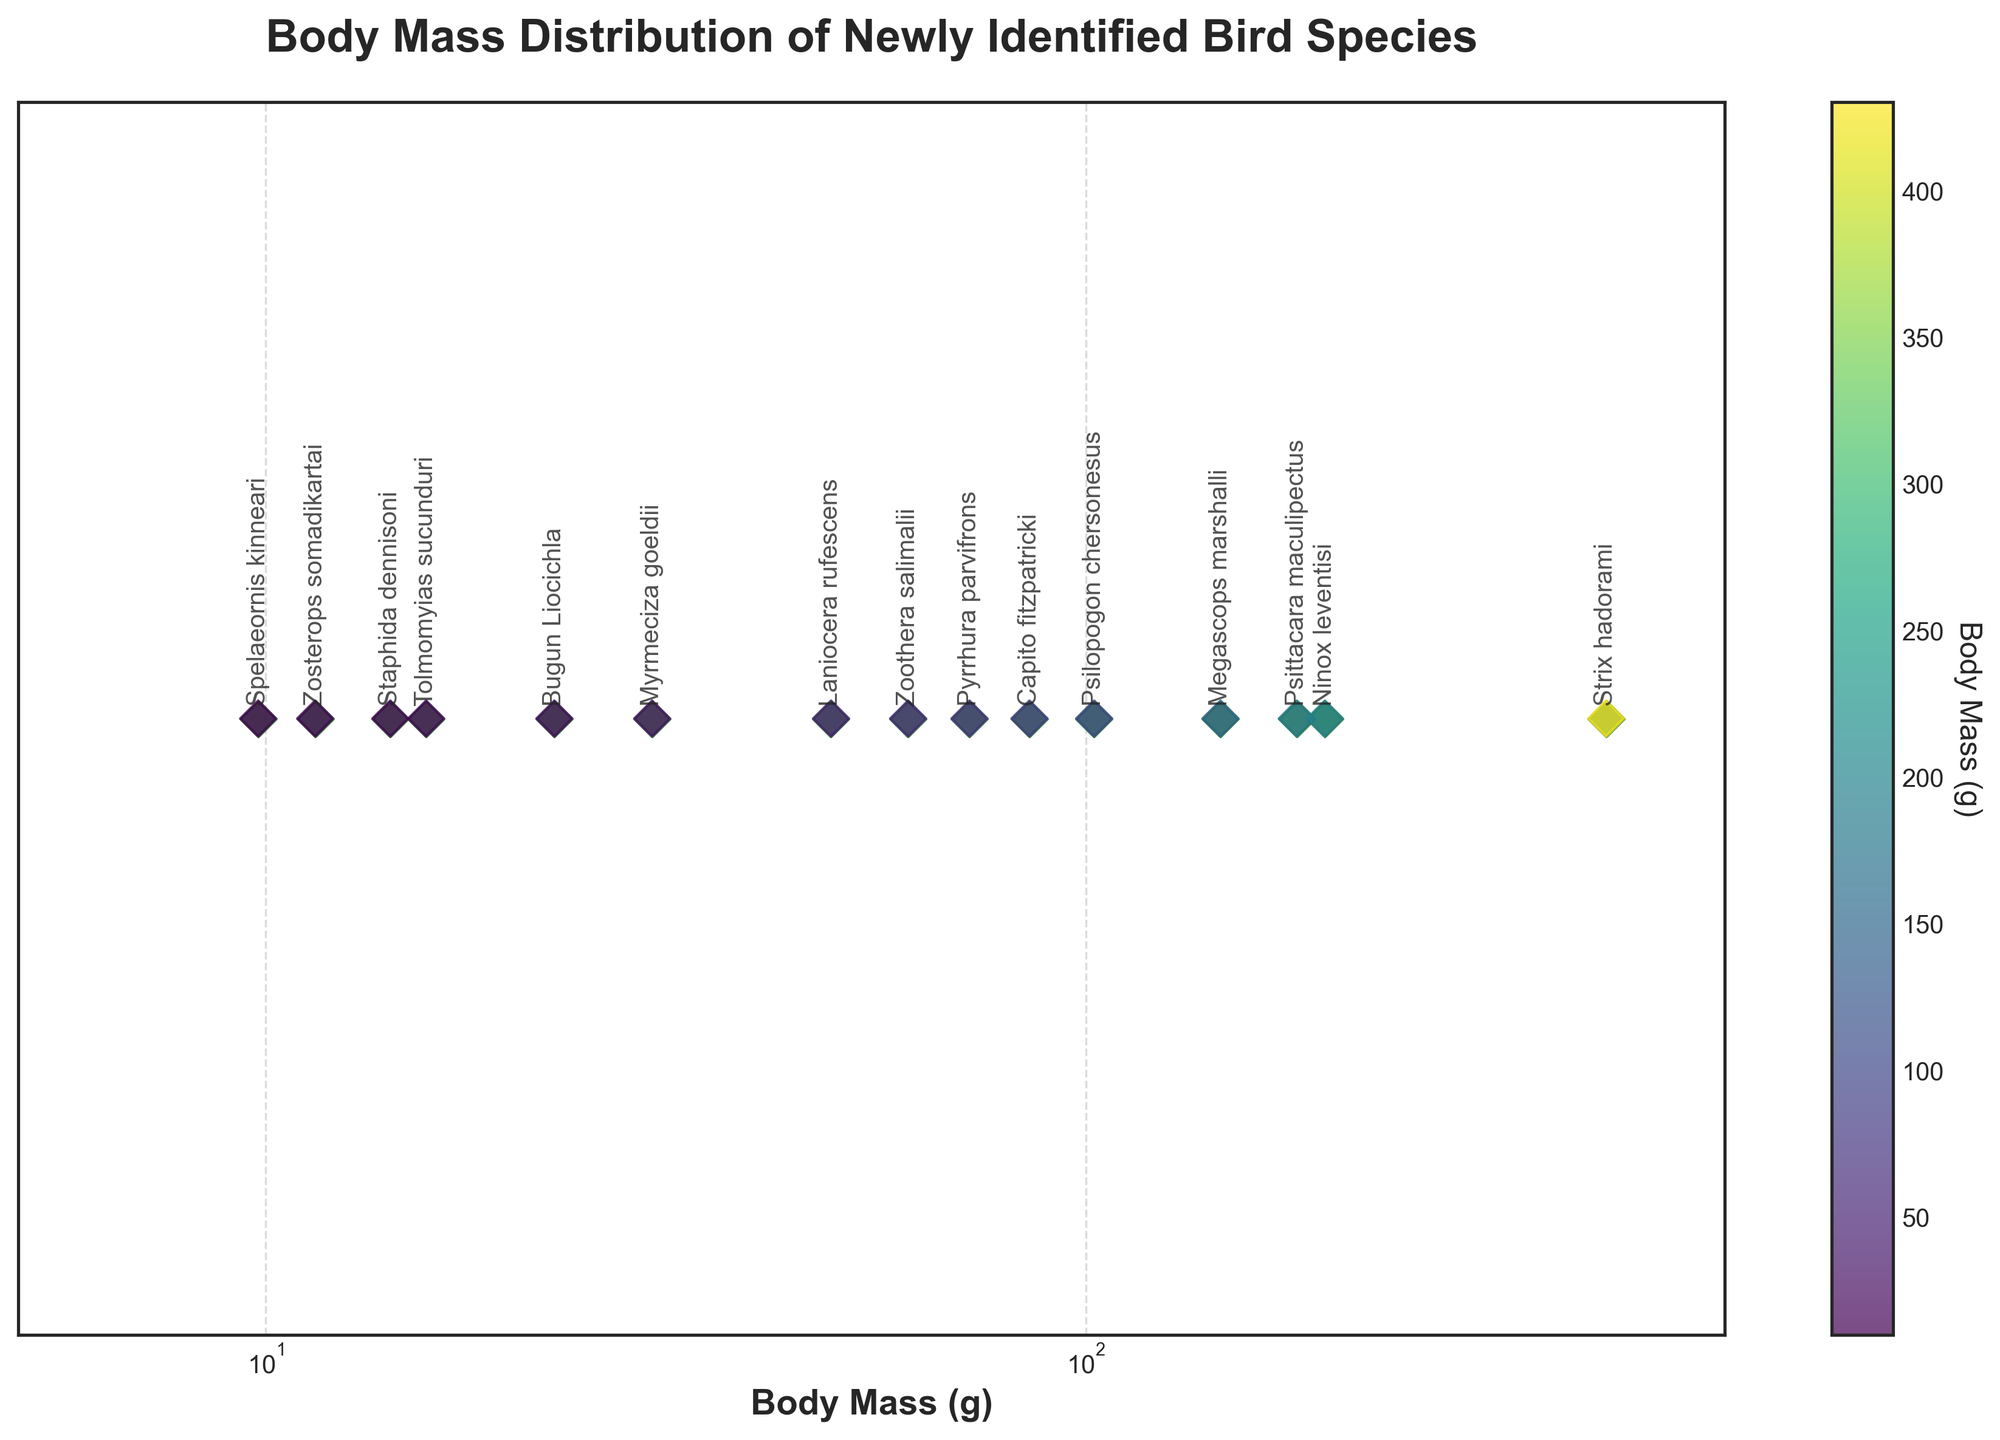what is the title of the plot? The title of the plot is usually displayed prominently at the top. Here, it reads 'Body Mass Distribution of Newly Identified Bird Species'. Readers can easily identify this from the top of the figure.
Answer: Body Mass Distribution of Newly Identified Bird Species Which bird species have the smallest body mass? To find the bird species with the smallest body mass, look for the data point located farthest to the left on the x-axis. The annotation near this point will reveal the species.
Answer: Spelaeornis kinneari What is the range of body mass values for the bird species? The range is calculated by subtracting the smallest value from the largest value on the x-axis. The smallest value is 9.8 g (Spelaeornis kinneari) and the largest is 430.2 g (Strix hadorami). Thus, the range is 430.2 - 9.8.
Answer: 420.4 g Which bird species is closest in body mass to 100 grams? Identify the data point closest to 100 grams on the x-axis and then look for the annotated species name just above it. The species closest to this value without exceeding it is Psilopogon chersonesus at 102.3 grams.
Answer: Psilopogon chersonesus Which species has a body mass greater than 200 grams? Any species with a data point positioned to the right of the 200-gram mark on the x-axis will qualify. The species that meet this criterion are Strix hadorami at 430.2 grams and Ninox leventisi at 195.4 grams.
Answer: Strix hadorami How many bird species have a body mass less than 100 grams? Count the number of data points positioned to the left of the 100-gram mark on the x-axis. The annotations will provide the species names.
Answer: 11 species Which two bird species have the closest body masses to each other? Compare the distances between adjacent data points to find the smallest gap. Bugun Liocichla (22.5 g) and Myrmeciza goeldii (29.6 g) have the smallest difference in body mass, which is 29.6 - 22.5.
Answer: Bugun Liocichla and Myrmeciza goeldii What color is used for the data points in the plot? The data points are represented with a color that stands out for visibility. In this plot, the color used is a dark green.
Answer: Dark green Are the body mass values displayed on a linear or a logarithmic scale? Observe the spacing of the tick marks on the x-axis. Linear scales have evenly spaced tick marks, whereas logarithmic scales have tick marks that increase by orders of magnitude. This plot uses a logarithmic scale.
Answer: Logarithmic scale 